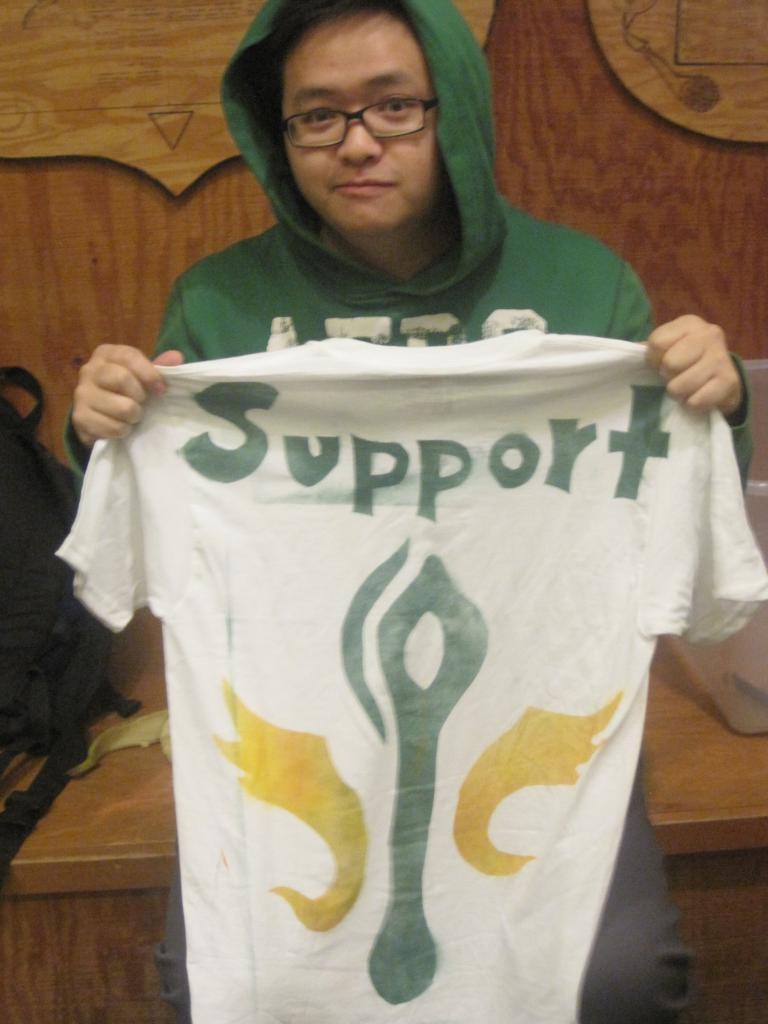Please provide a concise description of this image. In this picture there is a person wearing green dress and sitting is holding a white T-shirt which has support written on it and there is a bag in the left corner. 